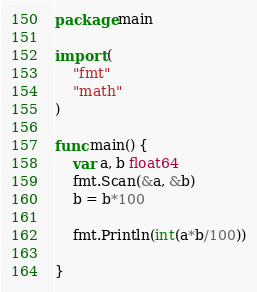<code> <loc_0><loc_0><loc_500><loc_500><_Go_>package main

import (
	"fmt"
	"math"
)

func main() {
	var a, b float64
	fmt.Scan(&a, &b)
	b = b*100

	fmt.Println(int(a*b/100))

}

</code> 